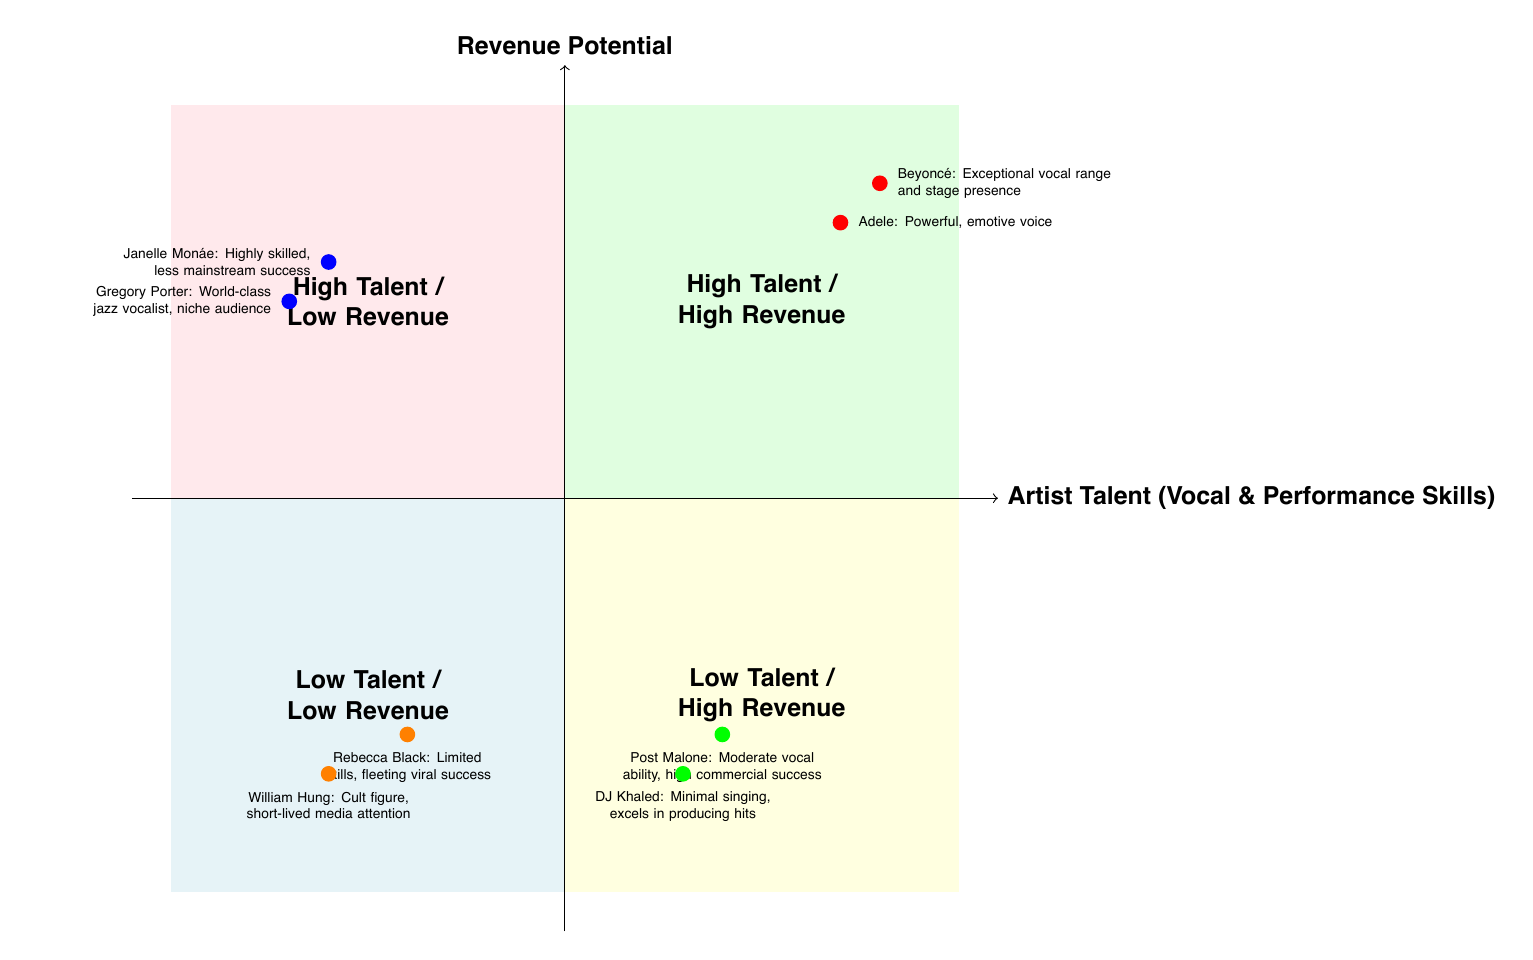What are the two examples in the "High Talent / High Revenue" quadrant? The "High Talent / High Revenue" quadrant includes two examples: Beyoncé and Adele. They exhibit exceptional vocal and performance skills along with significant commercial success.
Answer: Beyoncé, Adele How many artists are represented in the "Low Talent / Low Revenue" quadrant? In the "Low Talent / Low Revenue" quadrant, there are two artists represented: Rebecca Black and William Hung.
Answer: 2 Which artist is placed in the "High Talent / Low Revenue" quadrant? Janelle Monáe and Gregory Porter are both placed in the "High Talent / Low Revenue" quadrant, indicating their strong artistic skills but lower commercial success.
Answer: Janelle Monáe, Gregory Porter What characterizes the "Low Talent / High Revenue" quadrant? The "Low Talent / High Revenue" quadrant is characterized by artists who might have moderate talent but achieve significant sales and commercial success. For instance, Post Malone and DJ Khaled fall into this category.
Answer: Moderate talent, significant success Which artist is described as a "cult figure" in the "Low Talent / Low Revenue" quadrant? The artist described as a "cult figure" in the "Low Talent / Low Revenue" quadrant is William Hung, known for his limited vocal talent and brief media attention.
Answer: William Hung What is the main theme of the x-axis in this diagram? The main theme of the x-axis is "Artist Talent (Vocal & Performance Skills)", which evaluates the vocal ability and performance skills of the artists represented.
Answer: Artist Talent (Vocal & Performance Skills) How does the "High Talent / Low Revenue" quadrant relate to commercial success? The "High Talent / Low Revenue" quadrant indicates that while the artists possess exceptional talent, they have not achieved significant mainstream commercial success, such as Janelle Monáe and Gregory Porter.
Answer: Limited commercial success What is the overall purpose of this quadrant chart? The overall purpose of the quadrant chart is to visually represent the relationship between artist talent and revenue potential, categorizing artists based on where they fall along these axes.
Answer: Visual representation of talent vs. revenue potential 